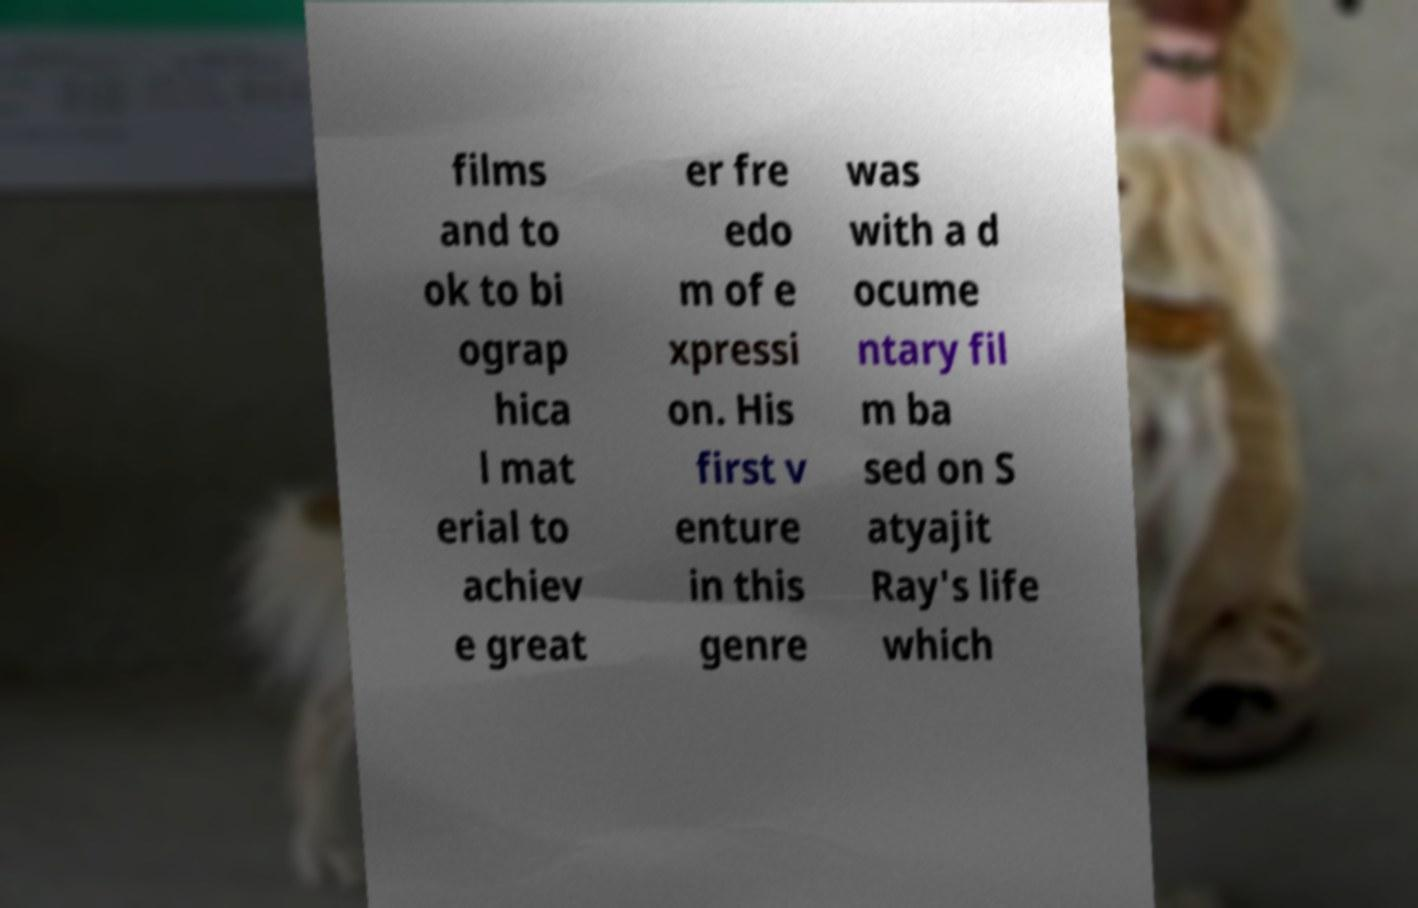Please read and relay the text visible in this image. What does it say? films and to ok to bi ograp hica l mat erial to achiev e great er fre edo m of e xpressi on. His first v enture in this genre was with a d ocume ntary fil m ba sed on S atyajit Ray's life which 